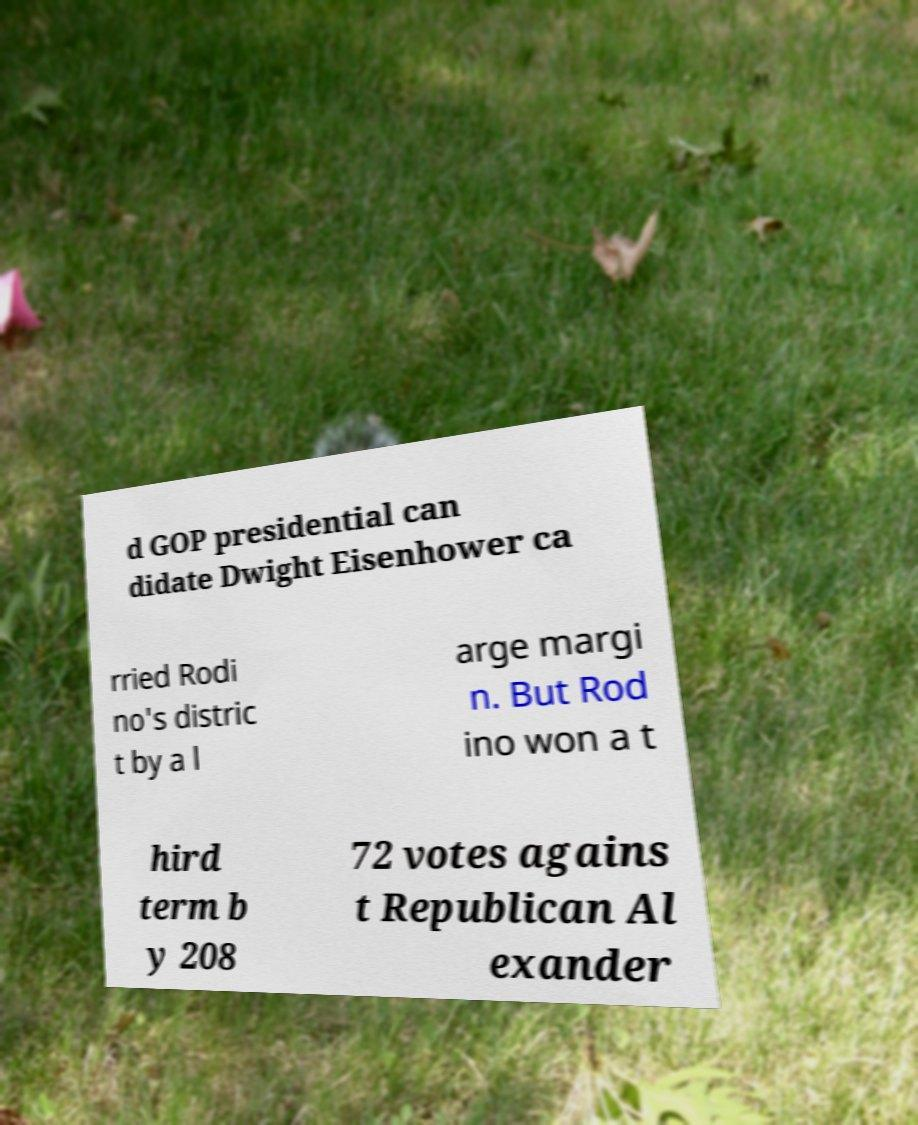Please read and relay the text visible in this image. What does it say? d GOP presidential can didate Dwight Eisenhower ca rried Rodi no's distric t by a l arge margi n. But Rod ino won a t hird term b y 208 72 votes agains t Republican Al exander 